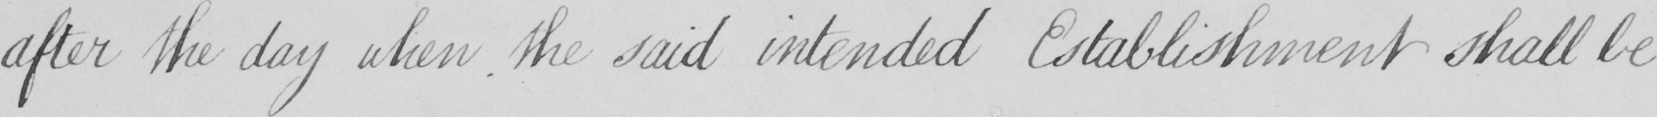Transcribe the text shown in this historical manuscript line. after the day when the said intended Establishment shall be 